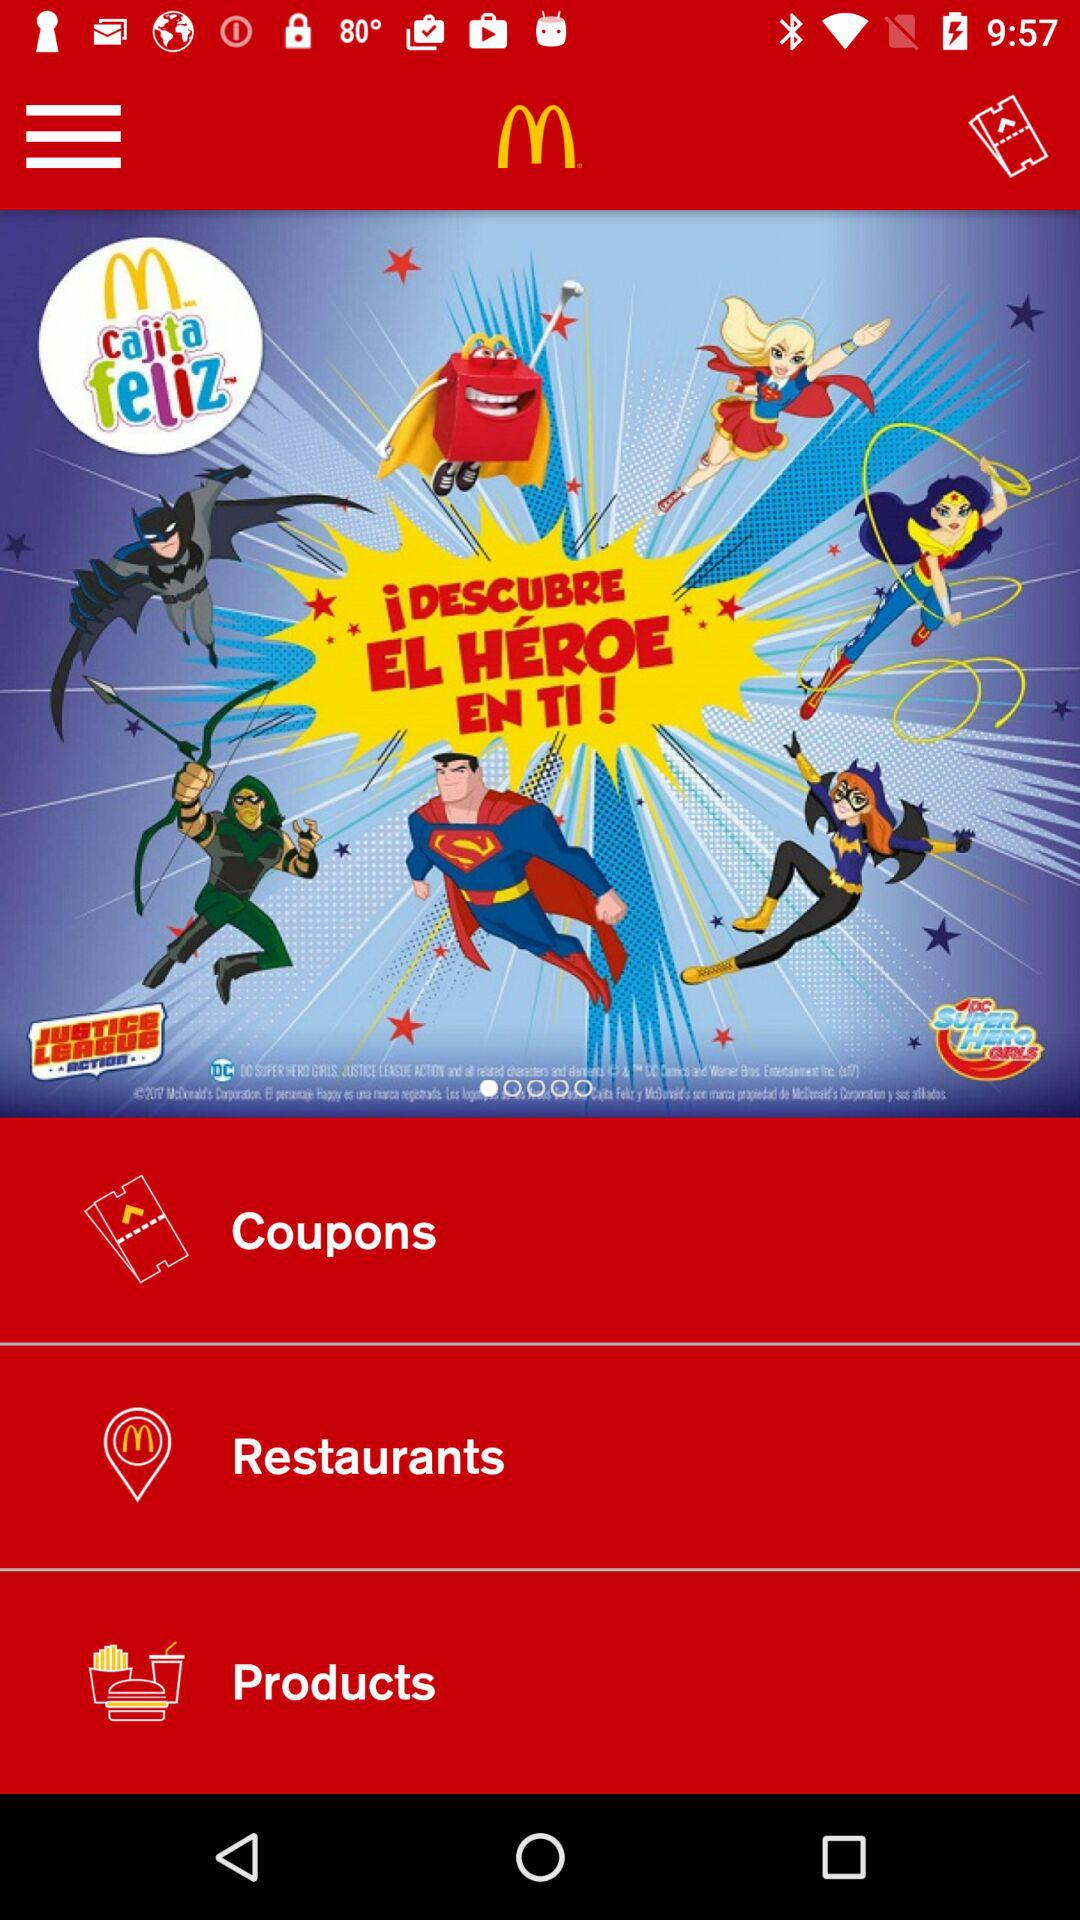What is the app name? The app name is "McDonald's". 